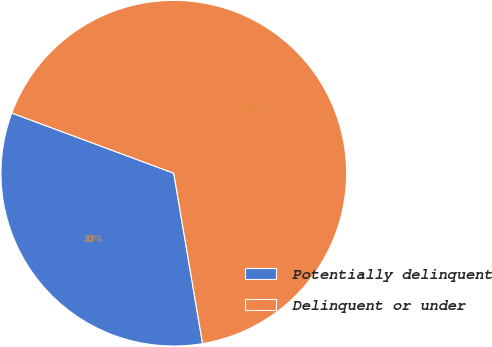<chart> <loc_0><loc_0><loc_500><loc_500><pie_chart><fcel>Potentially delinquent<fcel>Delinquent or under<nl><fcel>33.33%<fcel>66.67%<nl></chart> 